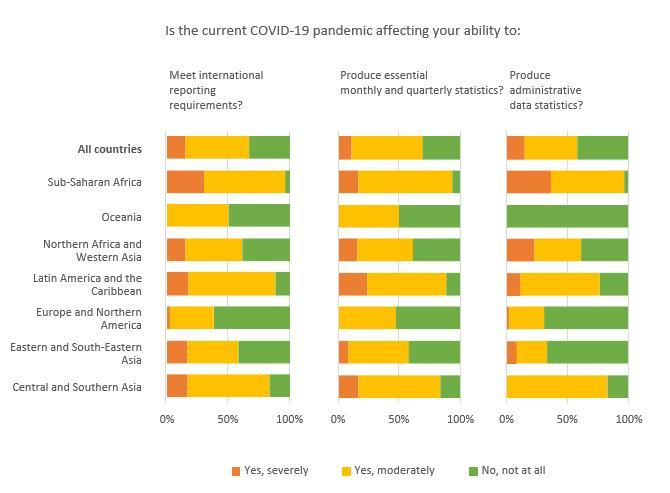What percentage of data shows that Covid-19 is severely affecting the ability to produce administrative data statistics of Oceania?
Answer the question with a short phrase. 0% What percentage of data shows that Covid-19 is severely affecting the ability to produce essential monthly and quarterly statistics of Europe and northern America? 0% What percentage of data shows that Covid-19 is severely affecting the ability to meet reporting requirements of Oceania? 0% What percentage of data shows that Covid-19 is severely affecting the ability to produce essential monthly and quarterly statistics of Oceania? 0% What percentage of data shows that Covid-19 is not at all affecting the ability to produce administrative data statistics of Central and Sub-Saharan Africa - more than 50 or less than 50? less than 50 What percentage of data shows that Covid-19 is moderately affecting the ability to produce administrative data statistics of Oceania? 0% What percentage of data shows that Covid-19 is not at all affecting the ability to produce essential monthly and quarterly statistics of Oceania? 50% What percentage of data shows that Covid-19 is not at all affecting the ability to produce administrative data statistics of Oceania? 100% What percentage of data shows that Covid-19 is severely affecting the ability to produce administrative data statistics of Central and southern Asia? 0% What percentage of data shows that Covid-19 is moderately affecting the ability to produce essential monthly and quarterly statistics of Oceania? 50% 